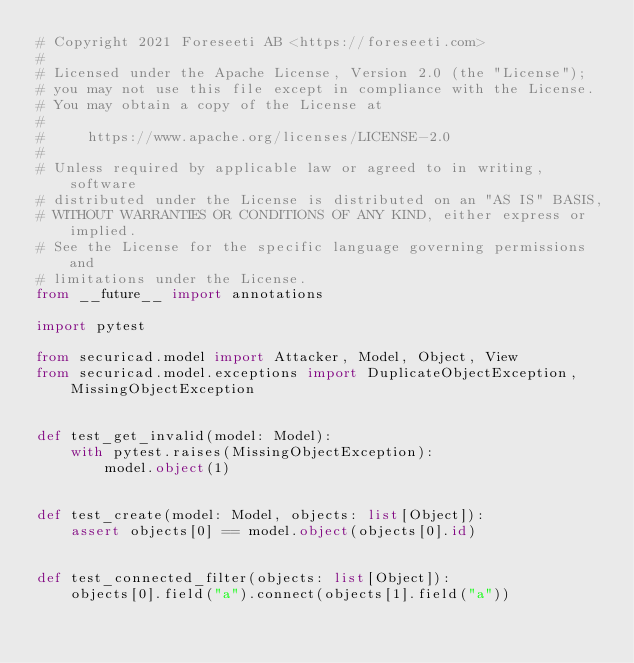Convert code to text. <code><loc_0><loc_0><loc_500><loc_500><_Python_># Copyright 2021 Foreseeti AB <https://foreseeti.com>
#
# Licensed under the Apache License, Version 2.0 (the "License");
# you may not use this file except in compliance with the License.
# You may obtain a copy of the License at
#
#     https://www.apache.org/licenses/LICENSE-2.0
#
# Unless required by applicable law or agreed to in writing, software
# distributed under the License is distributed on an "AS IS" BASIS,
# WITHOUT WARRANTIES OR CONDITIONS OF ANY KIND, either express or implied.
# See the License for the specific language governing permissions and
# limitations under the License.
from __future__ import annotations

import pytest

from securicad.model import Attacker, Model, Object, View
from securicad.model.exceptions import DuplicateObjectException, MissingObjectException


def test_get_invalid(model: Model):
    with pytest.raises(MissingObjectException):
        model.object(1)


def test_create(model: Model, objects: list[Object]):
    assert objects[0] == model.object(objects[0].id)


def test_connected_filter(objects: list[Object]):
    objects[0].field("a").connect(objects[1].field("a"))</code> 